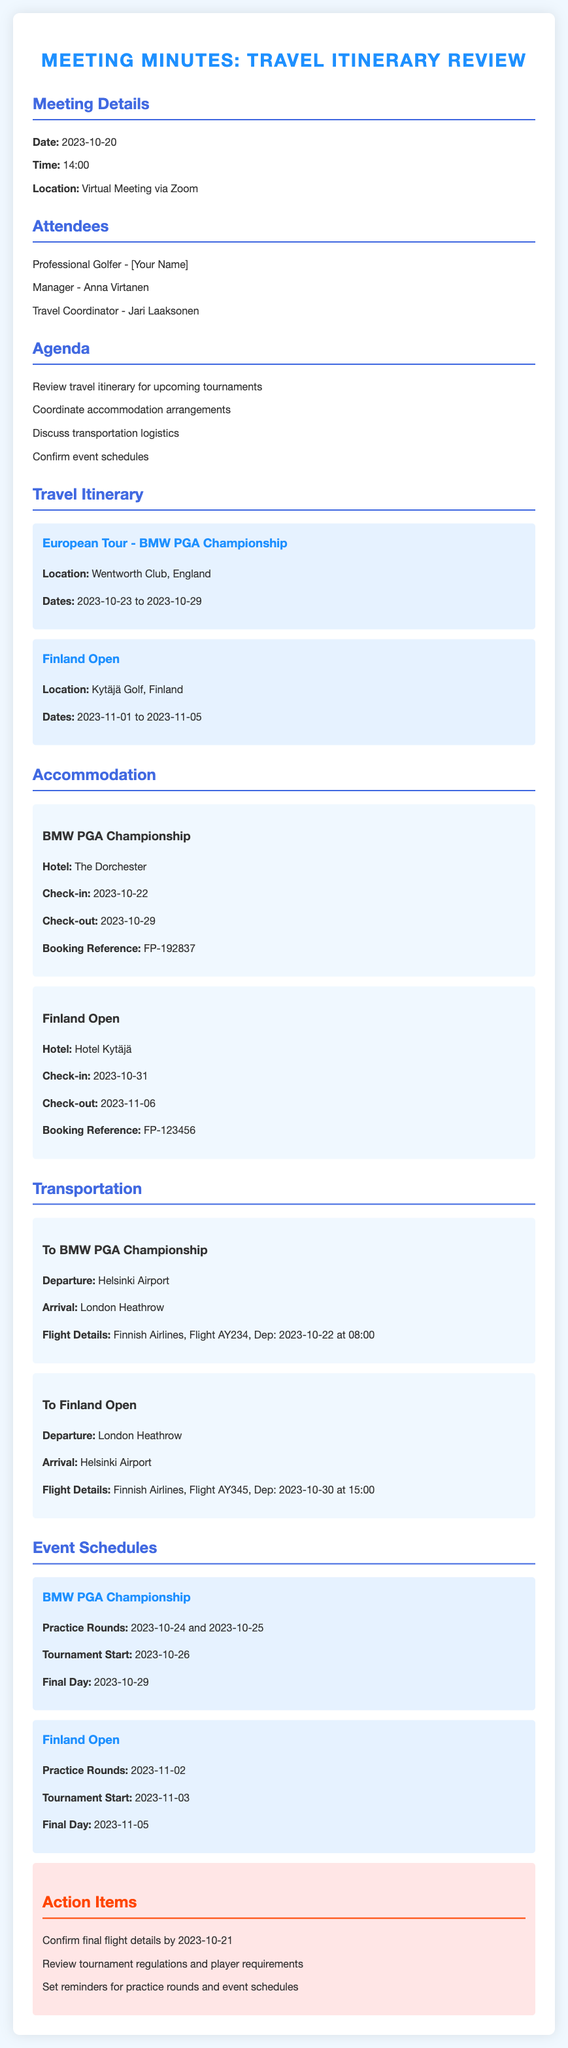what is the date of the meeting? The meeting date is explicitly stated in the document under Meeting Details.
Answer: 2023-10-20 who is the travel coordinator? The name of the travel coordinator is listed among the attendees.
Answer: Jari Laaksonen which hotel is booked for the BMW PGA Championship? The hotel for the BMW PGA Championship is specified in the Accommodation section.
Answer: The Dorchester what is the flight number for the departure to the BMW PGA Championship? The flight details for the BMW PGA Championship transportation are outlined, including the flight number.
Answer: AY234 what are the practice round dates for the Finland Open? The practice round dates for the Finland Open are mentioned under Event Schedules.
Answer: 2023-11-02 how long is the stay at The Dorchester? The check-in and check-out dates provide the duration of stay at The Dorchester.
Answer: 7 days what is the method of transportation to the Finland Open? The mode of transportation to the Finland Open is not explicitly stated; however, it is assumed to be a flight.
Answer: Flight what are the action items for final preparations? The action items for final preparations are listed in the Action Items section.
Answer: Confirm final flight details by 2023-10-21, review tournament regulations, set reminders for practice rounds what is the location of the European Tour - BMW PGA Championship? The location for the BMW PGA Championship is detailed in the Travel Itinerary section.
Answer: Wentworth Club, England 